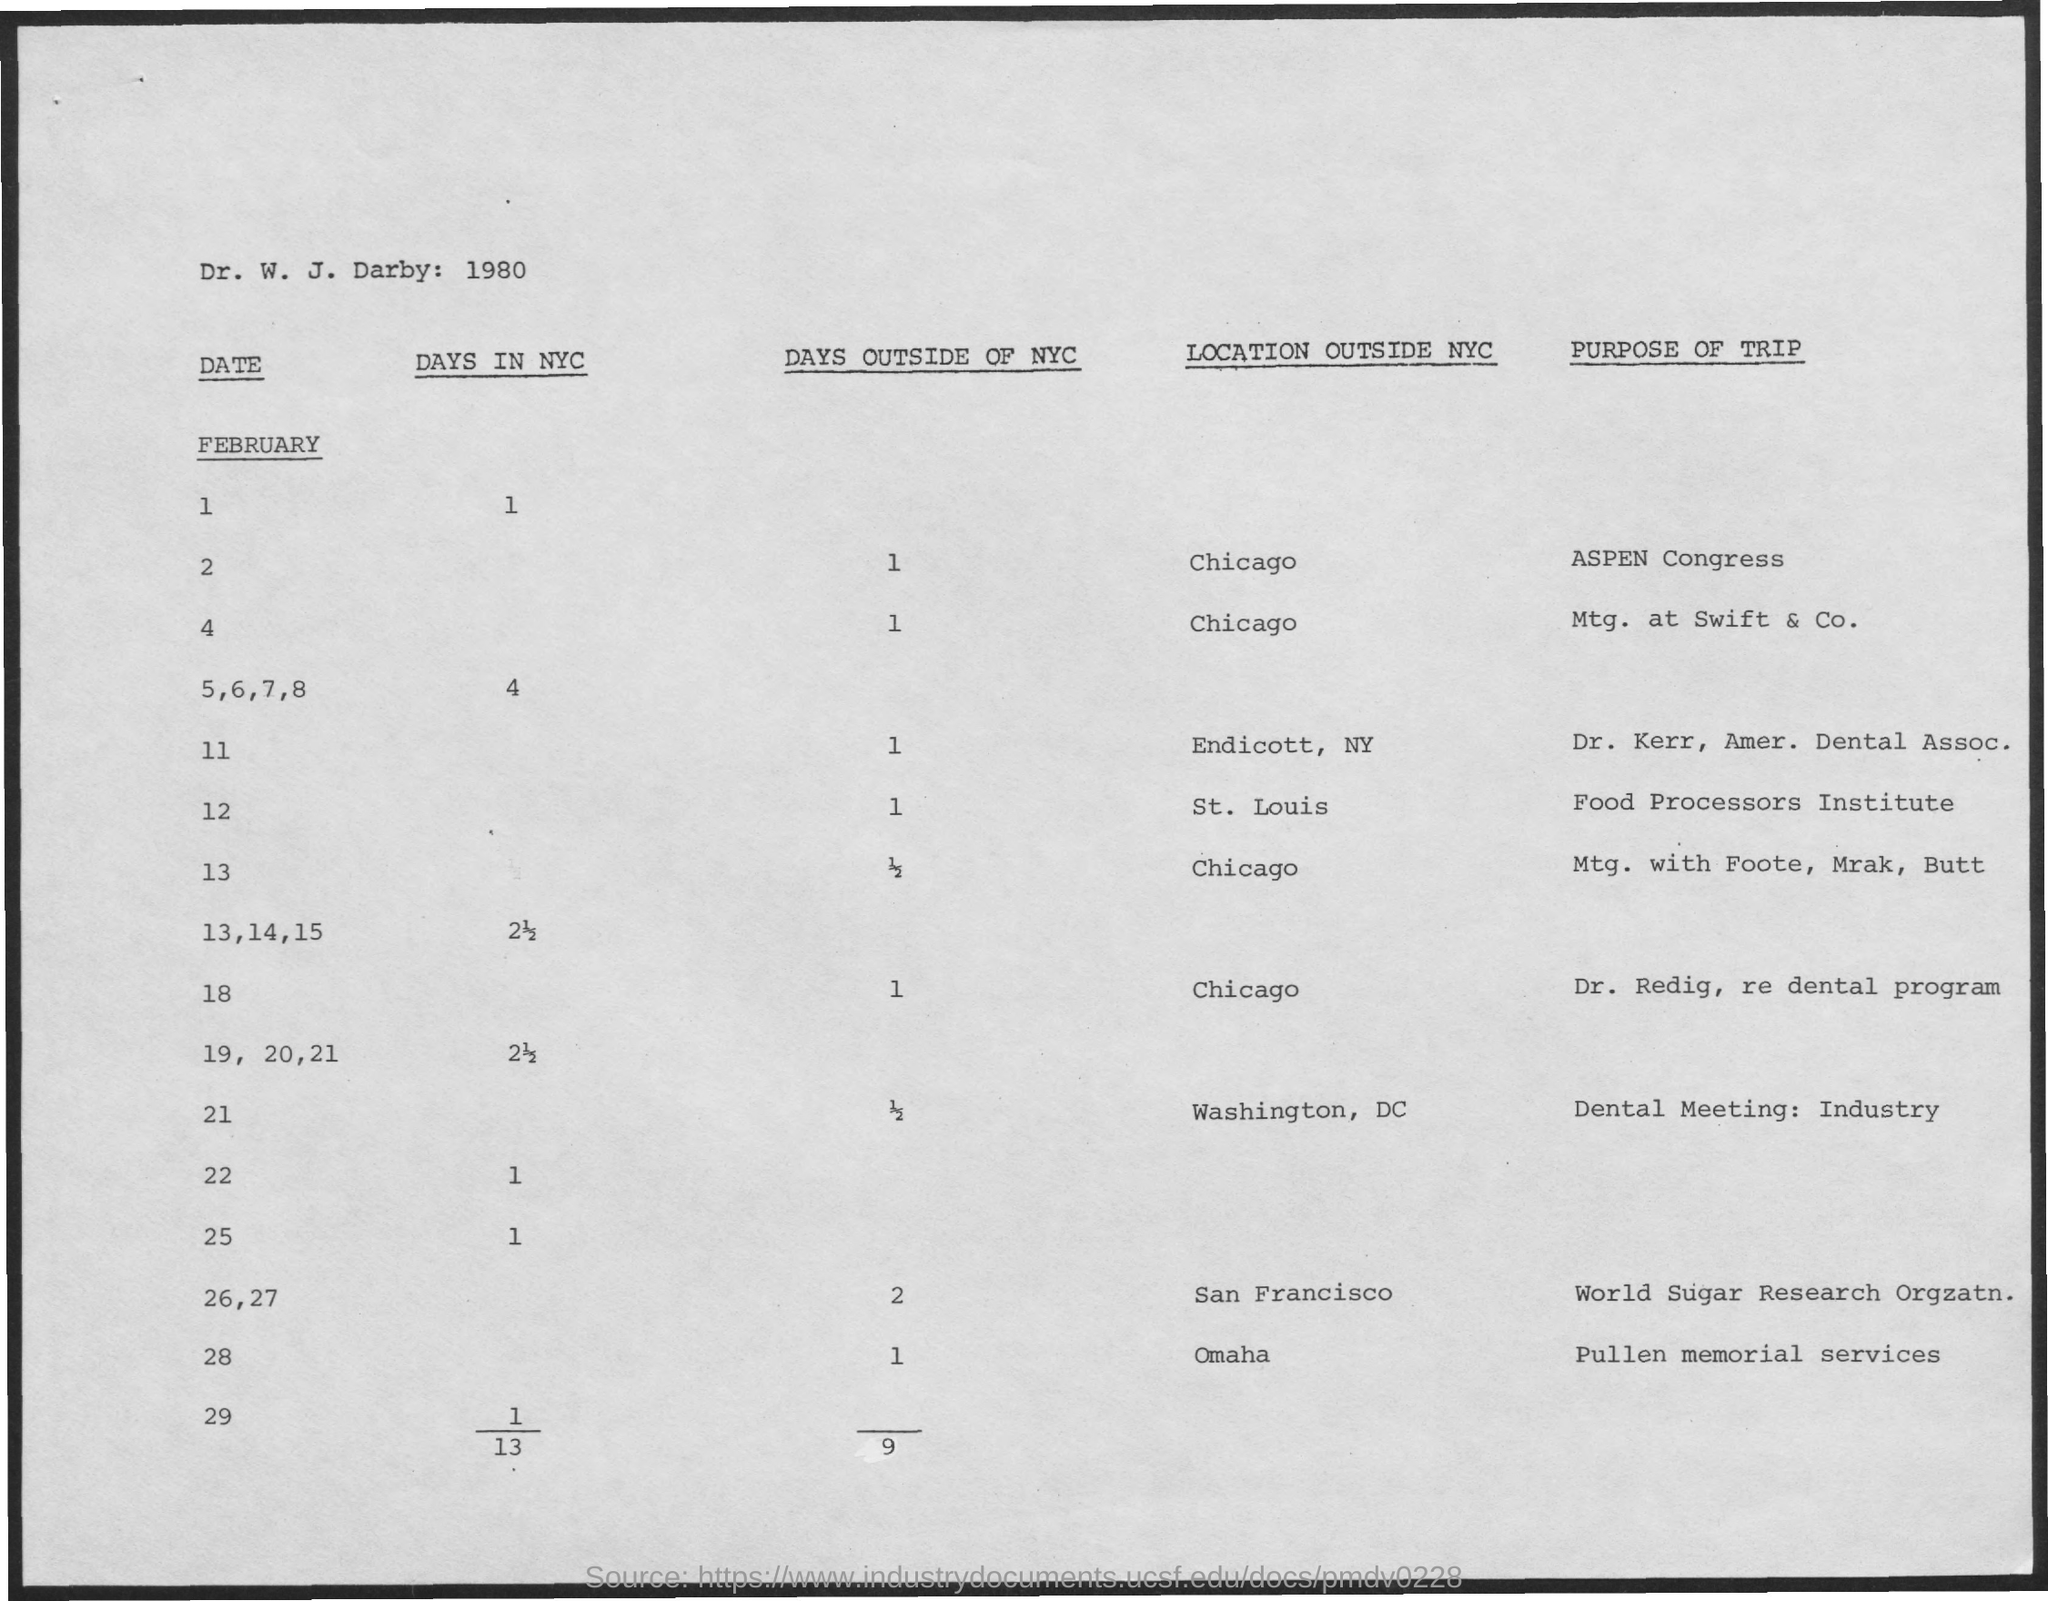Specify some key components in this picture. What are the number of days outside of New York City for February 12th? One... As of February 13th, there have been 1/2 days outside of NYC. As of February 11, the number of days outside of New York City is 1. On February 1st, the number of days in NYC is 1. There were one day outside of New York City on February 2. 